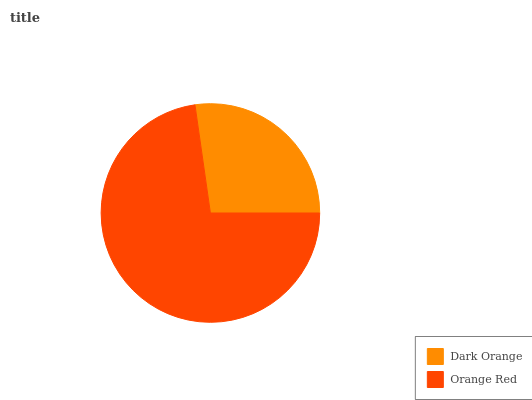Is Dark Orange the minimum?
Answer yes or no. Yes. Is Orange Red the maximum?
Answer yes or no. Yes. Is Orange Red the minimum?
Answer yes or no. No. Is Orange Red greater than Dark Orange?
Answer yes or no. Yes. Is Dark Orange less than Orange Red?
Answer yes or no. Yes. Is Dark Orange greater than Orange Red?
Answer yes or no. No. Is Orange Red less than Dark Orange?
Answer yes or no. No. Is Orange Red the high median?
Answer yes or no. Yes. Is Dark Orange the low median?
Answer yes or no. Yes. Is Dark Orange the high median?
Answer yes or no. No. Is Orange Red the low median?
Answer yes or no. No. 